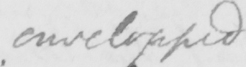What is written in this line of handwriting? envelopped 